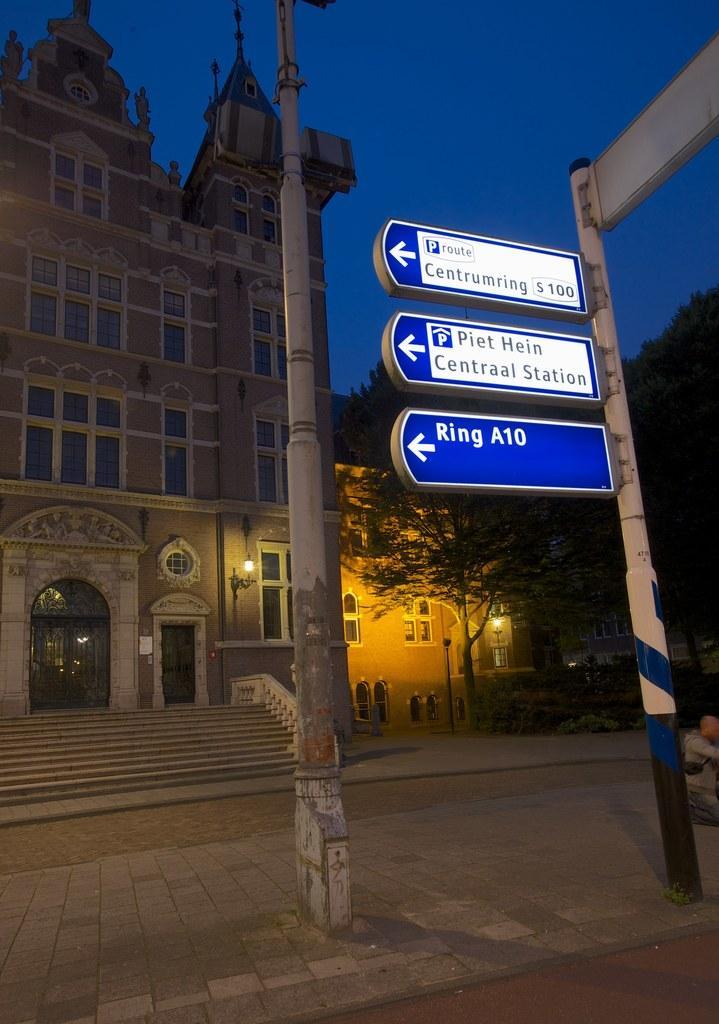In one or two sentences, can you explain what this image depicts? In the image I can see a place where we have some houses, buildings and also I can see some poles to which there are some boards. 